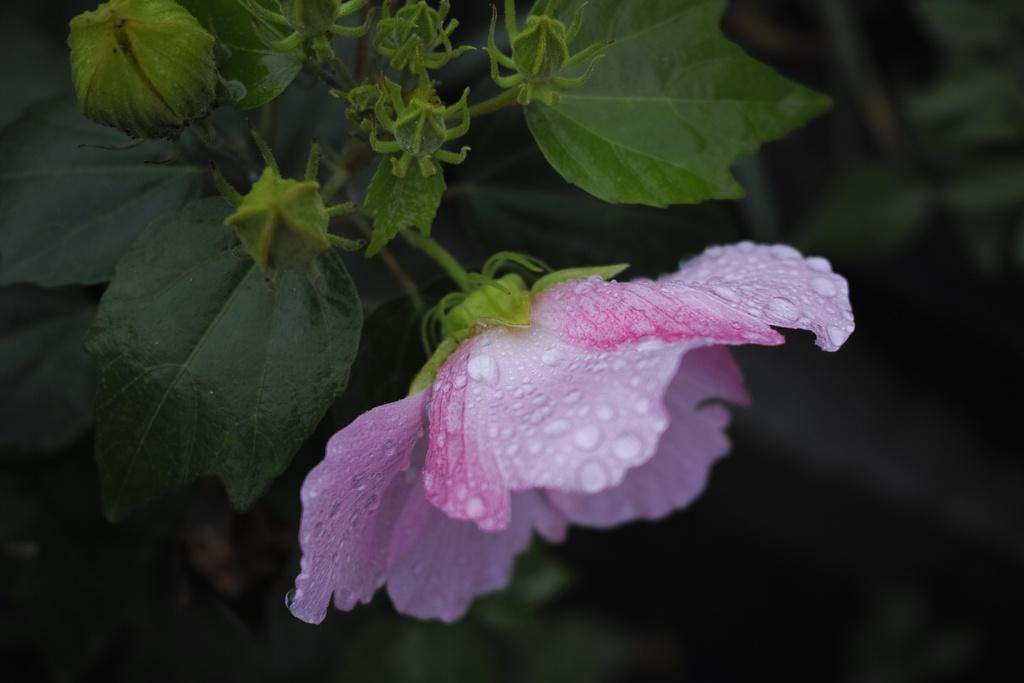How would you summarize this image in a sentence or two? In this image we can see a flower, buds, and leaves. There is a dark background. 